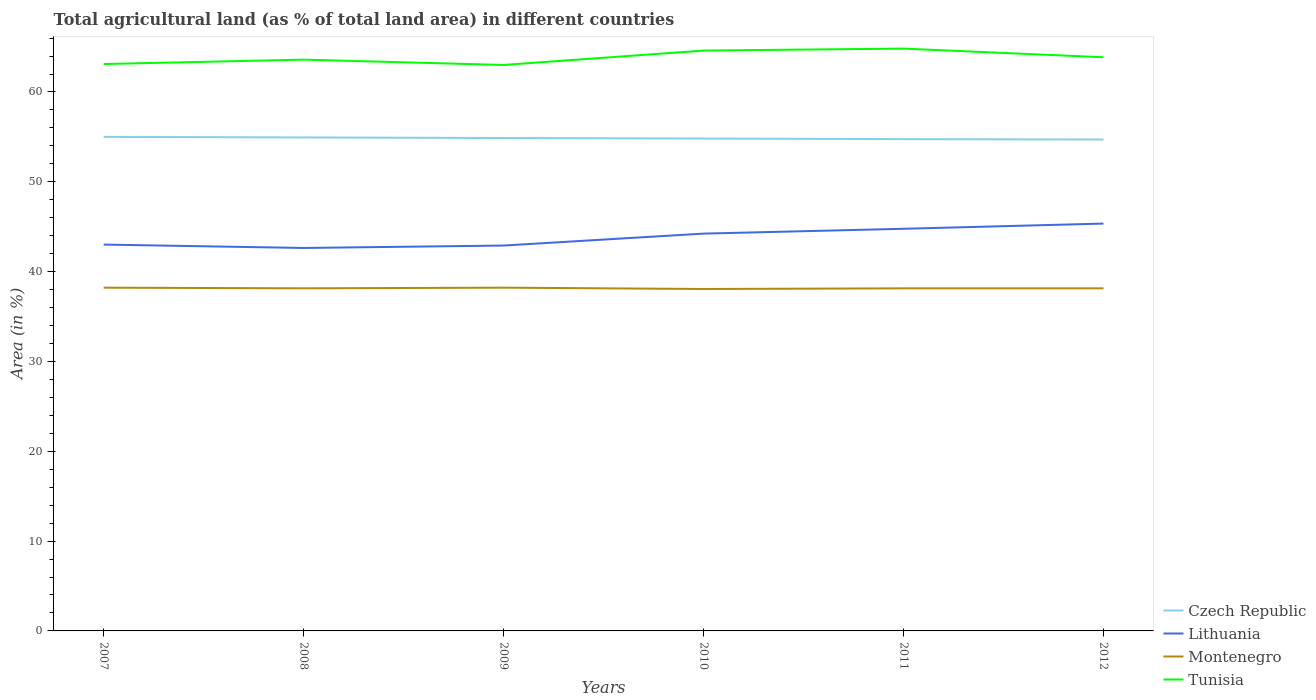Across all years, what is the maximum percentage of agricultural land in Czech Republic?
Provide a short and direct response. 54.71. In which year was the percentage of agricultural land in Czech Republic maximum?
Provide a short and direct response. 2012. What is the total percentage of agricultural land in Tunisia in the graph?
Provide a succinct answer. 0.75. What is the difference between the highest and the second highest percentage of agricultural land in Montenegro?
Offer a terse response. 0.15. What is the difference between the highest and the lowest percentage of agricultural land in Tunisia?
Make the answer very short. 3. Is the percentage of agricultural land in Czech Republic strictly greater than the percentage of agricultural land in Montenegro over the years?
Give a very brief answer. No. How many lines are there?
Your answer should be very brief. 4. How many years are there in the graph?
Keep it short and to the point. 6. Does the graph contain grids?
Offer a very short reply. No. How many legend labels are there?
Keep it short and to the point. 4. What is the title of the graph?
Offer a terse response. Total agricultural land (as % of total land area) in different countries. Does "American Samoa" appear as one of the legend labels in the graph?
Your answer should be compact. No. What is the label or title of the X-axis?
Provide a succinct answer. Years. What is the label or title of the Y-axis?
Offer a very short reply. Area (in %). What is the Area (in %) in Czech Republic in 2007?
Offer a very short reply. 55. What is the Area (in %) in Lithuania in 2007?
Provide a short and direct response. 43.01. What is the Area (in %) of Montenegro in 2007?
Provide a short and direct response. 38.22. What is the Area (in %) in Tunisia in 2007?
Offer a terse response. 63.11. What is the Area (in %) of Czech Republic in 2008?
Your answer should be very brief. 54.94. What is the Area (in %) in Lithuania in 2008?
Offer a terse response. 42.63. What is the Area (in %) of Montenegro in 2008?
Your answer should be compact. 38.14. What is the Area (in %) of Tunisia in 2008?
Provide a succinct answer. 63.6. What is the Area (in %) in Czech Republic in 2009?
Your answer should be very brief. 54.87. What is the Area (in %) of Lithuania in 2009?
Your answer should be compact. 42.9. What is the Area (in %) of Montenegro in 2009?
Your response must be concise. 38.22. What is the Area (in %) of Tunisia in 2009?
Ensure brevity in your answer.  63.01. What is the Area (in %) in Czech Republic in 2010?
Offer a very short reply. 54.82. What is the Area (in %) of Lithuania in 2010?
Offer a terse response. 44.23. What is the Area (in %) of Montenegro in 2010?
Keep it short and to the point. 38.07. What is the Area (in %) of Tunisia in 2010?
Your answer should be compact. 64.61. What is the Area (in %) of Czech Republic in 2011?
Ensure brevity in your answer.  54.75. What is the Area (in %) of Lithuania in 2011?
Ensure brevity in your answer.  44.77. What is the Area (in %) of Montenegro in 2011?
Make the answer very short. 38.14. What is the Area (in %) in Tunisia in 2011?
Give a very brief answer. 64.83. What is the Area (in %) in Czech Republic in 2012?
Your answer should be very brief. 54.71. What is the Area (in %) of Lithuania in 2012?
Keep it short and to the point. 45.35. What is the Area (in %) in Montenegro in 2012?
Your answer should be very brief. 38.14. What is the Area (in %) in Tunisia in 2012?
Ensure brevity in your answer.  63.86. Across all years, what is the maximum Area (in %) in Czech Republic?
Ensure brevity in your answer.  55. Across all years, what is the maximum Area (in %) in Lithuania?
Provide a short and direct response. 45.35. Across all years, what is the maximum Area (in %) of Montenegro?
Provide a succinct answer. 38.22. Across all years, what is the maximum Area (in %) of Tunisia?
Your response must be concise. 64.83. Across all years, what is the minimum Area (in %) of Czech Republic?
Offer a terse response. 54.71. Across all years, what is the minimum Area (in %) of Lithuania?
Give a very brief answer. 42.63. Across all years, what is the minimum Area (in %) in Montenegro?
Offer a terse response. 38.07. Across all years, what is the minimum Area (in %) of Tunisia?
Offer a terse response. 63.01. What is the total Area (in %) in Czech Republic in the graph?
Offer a terse response. 329.09. What is the total Area (in %) of Lithuania in the graph?
Give a very brief answer. 262.9. What is the total Area (in %) of Montenegro in the graph?
Provide a short and direct response. 228.92. What is the total Area (in %) in Tunisia in the graph?
Offer a terse response. 383.03. What is the difference between the Area (in %) in Czech Republic in 2007 and that in 2008?
Ensure brevity in your answer.  0.06. What is the difference between the Area (in %) in Lithuania in 2007 and that in 2008?
Provide a succinct answer. 0.38. What is the difference between the Area (in %) of Montenegro in 2007 and that in 2008?
Offer a very short reply. 0.07. What is the difference between the Area (in %) of Tunisia in 2007 and that in 2008?
Keep it short and to the point. -0.49. What is the difference between the Area (in %) in Czech Republic in 2007 and that in 2009?
Offer a terse response. 0.13. What is the difference between the Area (in %) of Lithuania in 2007 and that in 2009?
Your answer should be very brief. 0.11. What is the difference between the Area (in %) of Montenegro in 2007 and that in 2009?
Ensure brevity in your answer.  0. What is the difference between the Area (in %) of Tunisia in 2007 and that in 2009?
Provide a succinct answer. 0.1. What is the difference between the Area (in %) in Czech Republic in 2007 and that in 2010?
Keep it short and to the point. 0.19. What is the difference between the Area (in %) of Lithuania in 2007 and that in 2010?
Ensure brevity in your answer.  -1.22. What is the difference between the Area (in %) in Montenegro in 2007 and that in 2010?
Keep it short and to the point. 0.15. What is the difference between the Area (in %) of Tunisia in 2007 and that in 2010?
Provide a short and direct response. -1.5. What is the difference between the Area (in %) of Czech Republic in 2007 and that in 2011?
Make the answer very short. 0.25. What is the difference between the Area (in %) of Lithuania in 2007 and that in 2011?
Give a very brief answer. -1.76. What is the difference between the Area (in %) of Montenegro in 2007 and that in 2011?
Provide a short and direct response. 0.07. What is the difference between the Area (in %) in Tunisia in 2007 and that in 2011?
Keep it short and to the point. -1.72. What is the difference between the Area (in %) of Czech Republic in 2007 and that in 2012?
Keep it short and to the point. 0.3. What is the difference between the Area (in %) in Lithuania in 2007 and that in 2012?
Give a very brief answer. -2.34. What is the difference between the Area (in %) of Montenegro in 2007 and that in 2012?
Your response must be concise. 0.07. What is the difference between the Area (in %) in Tunisia in 2007 and that in 2012?
Provide a short and direct response. -0.75. What is the difference between the Area (in %) in Czech Republic in 2008 and that in 2009?
Your answer should be compact. 0.06. What is the difference between the Area (in %) in Lithuania in 2008 and that in 2009?
Your answer should be compact. -0.27. What is the difference between the Area (in %) in Montenegro in 2008 and that in 2009?
Your answer should be compact. -0.07. What is the difference between the Area (in %) in Tunisia in 2008 and that in 2009?
Your answer should be compact. 0.59. What is the difference between the Area (in %) in Czech Republic in 2008 and that in 2010?
Offer a very short reply. 0.12. What is the difference between the Area (in %) of Lithuania in 2008 and that in 2010?
Give a very brief answer. -1.6. What is the difference between the Area (in %) in Montenegro in 2008 and that in 2010?
Ensure brevity in your answer.  0.07. What is the difference between the Area (in %) of Tunisia in 2008 and that in 2010?
Make the answer very short. -1.01. What is the difference between the Area (in %) in Czech Republic in 2008 and that in 2011?
Offer a very short reply. 0.19. What is the difference between the Area (in %) of Lithuania in 2008 and that in 2011?
Ensure brevity in your answer.  -2.14. What is the difference between the Area (in %) of Montenegro in 2008 and that in 2011?
Provide a short and direct response. 0. What is the difference between the Area (in %) in Tunisia in 2008 and that in 2011?
Offer a very short reply. -1.23. What is the difference between the Area (in %) of Czech Republic in 2008 and that in 2012?
Make the answer very short. 0.23. What is the difference between the Area (in %) in Lithuania in 2008 and that in 2012?
Offer a terse response. -2.71. What is the difference between the Area (in %) in Tunisia in 2008 and that in 2012?
Offer a very short reply. -0.26. What is the difference between the Area (in %) in Czech Republic in 2009 and that in 2010?
Your answer should be very brief. 0.06. What is the difference between the Area (in %) of Lithuania in 2009 and that in 2010?
Your answer should be compact. -1.33. What is the difference between the Area (in %) in Montenegro in 2009 and that in 2010?
Ensure brevity in your answer.  0.15. What is the difference between the Area (in %) in Tunisia in 2009 and that in 2010?
Your answer should be very brief. -1.6. What is the difference between the Area (in %) in Czech Republic in 2009 and that in 2011?
Make the answer very short. 0.12. What is the difference between the Area (in %) of Lithuania in 2009 and that in 2011?
Provide a succinct answer. -1.87. What is the difference between the Area (in %) of Montenegro in 2009 and that in 2011?
Provide a short and direct response. 0.07. What is the difference between the Area (in %) of Tunisia in 2009 and that in 2011?
Your response must be concise. -1.82. What is the difference between the Area (in %) of Czech Republic in 2009 and that in 2012?
Provide a succinct answer. 0.17. What is the difference between the Area (in %) in Lithuania in 2009 and that in 2012?
Keep it short and to the point. -2.45. What is the difference between the Area (in %) in Montenegro in 2009 and that in 2012?
Provide a succinct answer. 0.07. What is the difference between the Area (in %) in Tunisia in 2009 and that in 2012?
Keep it short and to the point. -0.86. What is the difference between the Area (in %) of Czech Republic in 2010 and that in 2011?
Make the answer very short. 0.06. What is the difference between the Area (in %) of Lithuania in 2010 and that in 2011?
Offer a terse response. -0.54. What is the difference between the Area (in %) in Montenegro in 2010 and that in 2011?
Your answer should be very brief. -0.07. What is the difference between the Area (in %) of Tunisia in 2010 and that in 2011?
Offer a terse response. -0.22. What is the difference between the Area (in %) in Czech Republic in 2010 and that in 2012?
Keep it short and to the point. 0.11. What is the difference between the Area (in %) of Lithuania in 2010 and that in 2012?
Offer a very short reply. -1.12. What is the difference between the Area (in %) of Montenegro in 2010 and that in 2012?
Offer a very short reply. -0.07. What is the difference between the Area (in %) of Tunisia in 2010 and that in 2012?
Provide a short and direct response. 0.75. What is the difference between the Area (in %) in Czech Republic in 2011 and that in 2012?
Ensure brevity in your answer.  0.04. What is the difference between the Area (in %) of Lithuania in 2011 and that in 2012?
Your response must be concise. -0.58. What is the difference between the Area (in %) in Montenegro in 2011 and that in 2012?
Your response must be concise. 0. What is the difference between the Area (in %) in Tunisia in 2011 and that in 2012?
Give a very brief answer. 0.97. What is the difference between the Area (in %) in Czech Republic in 2007 and the Area (in %) in Lithuania in 2008?
Keep it short and to the point. 12.37. What is the difference between the Area (in %) of Czech Republic in 2007 and the Area (in %) of Montenegro in 2008?
Provide a short and direct response. 16.86. What is the difference between the Area (in %) of Czech Republic in 2007 and the Area (in %) of Tunisia in 2008?
Your answer should be very brief. -8.6. What is the difference between the Area (in %) in Lithuania in 2007 and the Area (in %) in Montenegro in 2008?
Offer a very short reply. 4.87. What is the difference between the Area (in %) of Lithuania in 2007 and the Area (in %) of Tunisia in 2008?
Your response must be concise. -20.59. What is the difference between the Area (in %) in Montenegro in 2007 and the Area (in %) in Tunisia in 2008?
Make the answer very short. -25.39. What is the difference between the Area (in %) of Czech Republic in 2007 and the Area (in %) of Lithuania in 2009?
Your response must be concise. 12.1. What is the difference between the Area (in %) of Czech Republic in 2007 and the Area (in %) of Montenegro in 2009?
Keep it short and to the point. 16.79. What is the difference between the Area (in %) of Czech Republic in 2007 and the Area (in %) of Tunisia in 2009?
Provide a succinct answer. -8.01. What is the difference between the Area (in %) in Lithuania in 2007 and the Area (in %) in Montenegro in 2009?
Provide a short and direct response. 4.79. What is the difference between the Area (in %) in Lithuania in 2007 and the Area (in %) in Tunisia in 2009?
Your answer should be compact. -20. What is the difference between the Area (in %) of Montenegro in 2007 and the Area (in %) of Tunisia in 2009?
Provide a succinct answer. -24.79. What is the difference between the Area (in %) in Czech Republic in 2007 and the Area (in %) in Lithuania in 2010?
Keep it short and to the point. 10.77. What is the difference between the Area (in %) of Czech Republic in 2007 and the Area (in %) of Montenegro in 2010?
Your answer should be very brief. 16.94. What is the difference between the Area (in %) of Czech Republic in 2007 and the Area (in %) of Tunisia in 2010?
Offer a terse response. -9.61. What is the difference between the Area (in %) in Lithuania in 2007 and the Area (in %) in Montenegro in 2010?
Offer a very short reply. 4.94. What is the difference between the Area (in %) in Lithuania in 2007 and the Area (in %) in Tunisia in 2010?
Ensure brevity in your answer.  -21.6. What is the difference between the Area (in %) in Montenegro in 2007 and the Area (in %) in Tunisia in 2010?
Keep it short and to the point. -26.4. What is the difference between the Area (in %) of Czech Republic in 2007 and the Area (in %) of Lithuania in 2011?
Your answer should be compact. 10.23. What is the difference between the Area (in %) of Czech Republic in 2007 and the Area (in %) of Montenegro in 2011?
Keep it short and to the point. 16.86. What is the difference between the Area (in %) in Czech Republic in 2007 and the Area (in %) in Tunisia in 2011?
Your answer should be very brief. -9.83. What is the difference between the Area (in %) of Lithuania in 2007 and the Area (in %) of Montenegro in 2011?
Make the answer very short. 4.87. What is the difference between the Area (in %) of Lithuania in 2007 and the Area (in %) of Tunisia in 2011?
Offer a very short reply. -21.82. What is the difference between the Area (in %) of Montenegro in 2007 and the Area (in %) of Tunisia in 2011?
Offer a terse response. -26.61. What is the difference between the Area (in %) in Czech Republic in 2007 and the Area (in %) in Lithuania in 2012?
Offer a very short reply. 9.65. What is the difference between the Area (in %) of Czech Republic in 2007 and the Area (in %) of Montenegro in 2012?
Provide a short and direct response. 16.86. What is the difference between the Area (in %) in Czech Republic in 2007 and the Area (in %) in Tunisia in 2012?
Keep it short and to the point. -8.86. What is the difference between the Area (in %) of Lithuania in 2007 and the Area (in %) of Montenegro in 2012?
Your answer should be compact. 4.87. What is the difference between the Area (in %) of Lithuania in 2007 and the Area (in %) of Tunisia in 2012?
Provide a short and direct response. -20.85. What is the difference between the Area (in %) in Montenegro in 2007 and the Area (in %) in Tunisia in 2012?
Keep it short and to the point. -25.65. What is the difference between the Area (in %) of Czech Republic in 2008 and the Area (in %) of Lithuania in 2009?
Offer a terse response. 12.03. What is the difference between the Area (in %) of Czech Republic in 2008 and the Area (in %) of Montenegro in 2009?
Provide a succinct answer. 16.72. What is the difference between the Area (in %) of Czech Republic in 2008 and the Area (in %) of Tunisia in 2009?
Make the answer very short. -8.07. What is the difference between the Area (in %) of Lithuania in 2008 and the Area (in %) of Montenegro in 2009?
Keep it short and to the point. 4.42. What is the difference between the Area (in %) of Lithuania in 2008 and the Area (in %) of Tunisia in 2009?
Give a very brief answer. -20.37. What is the difference between the Area (in %) in Montenegro in 2008 and the Area (in %) in Tunisia in 2009?
Your answer should be very brief. -24.87. What is the difference between the Area (in %) of Czech Republic in 2008 and the Area (in %) of Lithuania in 2010?
Offer a very short reply. 10.71. What is the difference between the Area (in %) in Czech Republic in 2008 and the Area (in %) in Montenegro in 2010?
Make the answer very short. 16.87. What is the difference between the Area (in %) of Czech Republic in 2008 and the Area (in %) of Tunisia in 2010?
Your answer should be compact. -9.67. What is the difference between the Area (in %) in Lithuania in 2008 and the Area (in %) in Montenegro in 2010?
Offer a terse response. 4.57. What is the difference between the Area (in %) in Lithuania in 2008 and the Area (in %) in Tunisia in 2010?
Your answer should be compact. -21.98. What is the difference between the Area (in %) in Montenegro in 2008 and the Area (in %) in Tunisia in 2010?
Make the answer very short. -26.47. What is the difference between the Area (in %) in Czech Republic in 2008 and the Area (in %) in Lithuania in 2011?
Your response must be concise. 10.17. What is the difference between the Area (in %) of Czech Republic in 2008 and the Area (in %) of Montenegro in 2011?
Make the answer very short. 16.8. What is the difference between the Area (in %) of Czech Republic in 2008 and the Area (in %) of Tunisia in 2011?
Your answer should be compact. -9.89. What is the difference between the Area (in %) in Lithuania in 2008 and the Area (in %) in Montenegro in 2011?
Give a very brief answer. 4.49. What is the difference between the Area (in %) of Lithuania in 2008 and the Area (in %) of Tunisia in 2011?
Give a very brief answer. -22.2. What is the difference between the Area (in %) of Montenegro in 2008 and the Area (in %) of Tunisia in 2011?
Provide a succinct answer. -26.69. What is the difference between the Area (in %) in Czech Republic in 2008 and the Area (in %) in Lithuania in 2012?
Your answer should be compact. 9.59. What is the difference between the Area (in %) in Czech Republic in 2008 and the Area (in %) in Montenegro in 2012?
Provide a short and direct response. 16.8. What is the difference between the Area (in %) in Czech Republic in 2008 and the Area (in %) in Tunisia in 2012?
Your answer should be compact. -8.93. What is the difference between the Area (in %) of Lithuania in 2008 and the Area (in %) of Montenegro in 2012?
Provide a short and direct response. 4.49. What is the difference between the Area (in %) of Lithuania in 2008 and the Area (in %) of Tunisia in 2012?
Make the answer very short. -21.23. What is the difference between the Area (in %) in Montenegro in 2008 and the Area (in %) in Tunisia in 2012?
Offer a very short reply. -25.72. What is the difference between the Area (in %) in Czech Republic in 2009 and the Area (in %) in Lithuania in 2010?
Your answer should be very brief. 10.64. What is the difference between the Area (in %) of Czech Republic in 2009 and the Area (in %) of Montenegro in 2010?
Give a very brief answer. 16.81. What is the difference between the Area (in %) in Czech Republic in 2009 and the Area (in %) in Tunisia in 2010?
Your response must be concise. -9.74. What is the difference between the Area (in %) in Lithuania in 2009 and the Area (in %) in Montenegro in 2010?
Your answer should be compact. 4.84. What is the difference between the Area (in %) in Lithuania in 2009 and the Area (in %) in Tunisia in 2010?
Your response must be concise. -21.71. What is the difference between the Area (in %) of Montenegro in 2009 and the Area (in %) of Tunisia in 2010?
Your response must be concise. -26.4. What is the difference between the Area (in %) of Czech Republic in 2009 and the Area (in %) of Lithuania in 2011?
Make the answer very short. 10.1. What is the difference between the Area (in %) of Czech Republic in 2009 and the Area (in %) of Montenegro in 2011?
Your response must be concise. 16.73. What is the difference between the Area (in %) in Czech Republic in 2009 and the Area (in %) in Tunisia in 2011?
Your response must be concise. -9.96. What is the difference between the Area (in %) in Lithuania in 2009 and the Area (in %) in Montenegro in 2011?
Keep it short and to the point. 4.76. What is the difference between the Area (in %) in Lithuania in 2009 and the Area (in %) in Tunisia in 2011?
Provide a short and direct response. -21.93. What is the difference between the Area (in %) of Montenegro in 2009 and the Area (in %) of Tunisia in 2011?
Provide a succinct answer. -26.61. What is the difference between the Area (in %) in Czech Republic in 2009 and the Area (in %) in Lithuania in 2012?
Keep it short and to the point. 9.52. What is the difference between the Area (in %) of Czech Republic in 2009 and the Area (in %) of Montenegro in 2012?
Make the answer very short. 16.73. What is the difference between the Area (in %) in Czech Republic in 2009 and the Area (in %) in Tunisia in 2012?
Your answer should be very brief. -8.99. What is the difference between the Area (in %) in Lithuania in 2009 and the Area (in %) in Montenegro in 2012?
Offer a very short reply. 4.76. What is the difference between the Area (in %) of Lithuania in 2009 and the Area (in %) of Tunisia in 2012?
Your answer should be very brief. -20.96. What is the difference between the Area (in %) in Montenegro in 2009 and the Area (in %) in Tunisia in 2012?
Provide a succinct answer. -25.65. What is the difference between the Area (in %) of Czech Republic in 2010 and the Area (in %) of Lithuania in 2011?
Offer a very short reply. 10.05. What is the difference between the Area (in %) of Czech Republic in 2010 and the Area (in %) of Montenegro in 2011?
Provide a succinct answer. 16.67. What is the difference between the Area (in %) of Czech Republic in 2010 and the Area (in %) of Tunisia in 2011?
Your response must be concise. -10.01. What is the difference between the Area (in %) in Lithuania in 2010 and the Area (in %) in Montenegro in 2011?
Offer a terse response. 6.09. What is the difference between the Area (in %) of Lithuania in 2010 and the Area (in %) of Tunisia in 2011?
Your answer should be compact. -20.6. What is the difference between the Area (in %) of Montenegro in 2010 and the Area (in %) of Tunisia in 2011?
Give a very brief answer. -26.76. What is the difference between the Area (in %) of Czech Republic in 2010 and the Area (in %) of Lithuania in 2012?
Give a very brief answer. 9.47. What is the difference between the Area (in %) in Czech Republic in 2010 and the Area (in %) in Montenegro in 2012?
Offer a terse response. 16.67. What is the difference between the Area (in %) in Czech Republic in 2010 and the Area (in %) in Tunisia in 2012?
Keep it short and to the point. -9.05. What is the difference between the Area (in %) in Lithuania in 2010 and the Area (in %) in Montenegro in 2012?
Your response must be concise. 6.09. What is the difference between the Area (in %) of Lithuania in 2010 and the Area (in %) of Tunisia in 2012?
Your response must be concise. -19.63. What is the difference between the Area (in %) in Montenegro in 2010 and the Area (in %) in Tunisia in 2012?
Keep it short and to the point. -25.8. What is the difference between the Area (in %) of Czech Republic in 2011 and the Area (in %) of Lithuania in 2012?
Give a very brief answer. 9.4. What is the difference between the Area (in %) of Czech Republic in 2011 and the Area (in %) of Montenegro in 2012?
Your answer should be very brief. 16.61. What is the difference between the Area (in %) in Czech Republic in 2011 and the Area (in %) in Tunisia in 2012?
Offer a very short reply. -9.11. What is the difference between the Area (in %) of Lithuania in 2011 and the Area (in %) of Montenegro in 2012?
Your answer should be very brief. 6.63. What is the difference between the Area (in %) of Lithuania in 2011 and the Area (in %) of Tunisia in 2012?
Provide a succinct answer. -19.09. What is the difference between the Area (in %) of Montenegro in 2011 and the Area (in %) of Tunisia in 2012?
Ensure brevity in your answer.  -25.72. What is the average Area (in %) in Czech Republic per year?
Make the answer very short. 54.85. What is the average Area (in %) of Lithuania per year?
Make the answer very short. 43.82. What is the average Area (in %) in Montenegro per year?
Offer a terse response. 38.15. What is the average Area (in %) in Tunisia per year?
Ensure brevity in your answer.  63.84. In the year 2007, what is the difference between the Area (in %) in Czech Republic and Area (in %) in Lithuania?
Your response must be concise. 11.99. In the year 2007, what is the difference between the Area (in %) of Czech Republic and Area (in %) of Montenegro?
Ensure brevity in your answer.  16.79. In the year 2007, what is the difference between the Area (in %) of Czech Republic and Area (in %) of Tunisia?
Provide a short and direct response. -8.11. In the year 2007, what is the difference between the Area (in %) of Lithuania and Area (in %) of Montenegro?
Provide a succinct answer. 4.79. In the year 2007, what is the difference between the Area (in %) in Lithuania and Area (in %) in Tunisia?
Offer a very short reply. -20.1. In the year 2007, what is the difference between the Area (in %) of Montenegro and Area (in %) of Tunisia?
Your answer should be compact. -24.9. In the year 2008, what is the difference between the Area (in %) of Czech Republic and Area (in %) of Lithuania?
Ensure brevity in your answer.  12.3. In the year 2008, what is the difference between the Area (in %) in Czech Republic and Area (in %) in Montenegro?
Provide a succinct answer. 16.8. In the year 2008, what is the difference between the Area (in %) of Czech Republic and Area (in %) of Tunisia?
Your answer should be compact. -8.66. In the year 2008, what is the difference between the Area (in %) in Lithuania and Area (in %) in Montenegro?
Provide a succinct answer. 4.49. In the year 2008, what is the difference between the Area (in %) in Lithuania and Area (in %) in Tunisia?
Ensure brevity in your answer.  -20.97. In the year 2008, what is the difference between the Area (in %) in Montenegro and Area (in %) in Tunisia?
Your answer should be very brief. -25.46. In the year 2009, what is the difference between the Area (in %) in Czech Republic and Area (in %) in Lithuania?
Your response must be concise. 11.97. In the year 2009, what is the difference between the Area (in %) of Czech Republic and Area (in %) of Montenegro?
Make the answer very short. 16.66. In the year 2009, what is the difference between the Area (in %) in Czech Republic and Area (in %) in Tunisia?
Your answer should be compact. -8.13. In the year 2009, what is the difference between the Area (in %) in Lithuania and Area (in %) in Montenegro?
Offer a very short reply. 4.69. In the year 2009, what is the difference between the Area (in %) of Lithuania and Area (in %) of Tunisia?
Provide a succinct answer. -20.1. In the year 2009, what is the difference between the Area (in %) in Montenegro and Area (in %) in Tunisia?
Provide a succinct answer. -24.79. In the year 2010, what is the difference between the Area (in %) of Czech Republic and Area (in %) of Lithuania?
Provide a succinct answer. 10.58. In the year 2010, what is the difference between the Area (in %) in Czech Republic and Area (in %) in Montenegro?
Offer a terse response. 16.75. In the year 2010, what is the difference between the Area (in %) of Czech Republic and Area (in %) of Tunisia?
Offer a terse response. -9.8. In the year 2010, what is the difference between the Area (in %) in Lithuania and Area (in %) in Montenegro?
Offer a terse response. 6.17. In the year 2010, what is the difference between the Area (in %) in Lithuania and Area (in %) in Tunisia?
Ensure brevity in your answer.  -20.38. In the year 2010, what is the difference between the Area (in %) in Montenegro and Area (in %) in Tunisia?
Your response must be concise. -26.54. In the year 2011, what is the difference between the Area (in %) of Czech Republic and Area (in %) of Lithuania?
Keep it short and to the point. 9.98. In the year 2011, what is the difference between the Area (in %) of Czech Republic and Area (in %) of Montenegro?
Ensure brevity in your answer.  16.61. In the year 2011, what is the difference between the Area (in %) in Czech Republic and Area (in %) in Tunisia?
Ensure brevity in your answer.  -10.08. In the year 2011, what is the difference between the Area (in %) in Lithuania and Area (in %) in Montenegro?
Provide a succinct answer. 6.63. In the year 2011, what is the difference between the Area (in %) of Lithuania and Area (in %) of Tunisia?
Make the answer very short. -20.06. In the year 2011, what is the difference between the Area (in %) in Montenegro and Area (in %) in Tunisia?
Offer a terse response. -26.69. In the year 2012, what is the difference between the Area (in %) in Czech Republic and Area (in %) in Lithuania?
Keep it short and to the point. 9.36. In the year 2012, what is the difference between the Area (in %) in Czech Republic and Area (in %) in Montenegro?
Provide a short and direct response. 16.57. In the year 2012, what is the difference between the Area (in %) in Czech Republic and Area (in %) in Tunisia?
Offer a very short reply. -9.16. In the year 2012, what is the difference between the Area (in %) in Lithuania and Area (in %) in Montenegro?
Make the answer very short. 7.21. In the year 2012, what is the difference between the Area (in %) of Lithuania and Area (in %) of Tunisia?
Your answer should be compact. -18.52. In the year 2012, what is the difference between the Area (in %) in Montenegro and Area (in %) in Tunisia?
Your answer should be very brief. -25.72. What is the ratio of the Area (in %) in Lithuania in 2007 to that in 2008?
Your response must be concise. 1.01. What is the ratio of the Area (in %) in Tunisia in 2007 to that in 2008?
Offer a terse response. 0.99. What is the ratio of the Area (in %) in Czech Republic in 2007 to that in 2009?
Offer a very short reply. 1. What is the ratio of the Area (in %) in Lithuania in 2007 to that in 2009?
Your response must be concise. 1. What is the ratio of the Area (in %) in Montenegro in 2007 to that in 2009?
Keep it short and to the point. 1. What is the ratio of the Area (in %) in Czech Republic in 2007 to that in 2010?
Provide a short and direct response. 1. What is the ratio of the Area (in %) of Lithuania in 2007 to that in 2010?
Offer a terse response. 0.97. What is the ratio of the Area (in %) of Montenegro in 2007 to that in 2010?
Provide a succinct answer. 1. What is the ratio of the Area (in %) in Tunisia in 2007 to that in 2010?
Your answer should be compact. 0.98. What is the ratio of the Area (in %) in Lithuania in 2007 to that in 2011?
Make the answer very short. 0.96. What is the ratio of the Area (in %) of Tunisia in 2007 to that in 2011?
Make the answer very short. 0.97. What is the ratio of the Area (in %) in Czech Republic in 2007 to that in 2012?
Your answer should be compact. 1.01. What is the ratio of the Area (in %) in Lithuania in 2007 to that in 2012?
Offer a terse response. 0.95. What is the ratio of the Area (in %) of Czech Republic in 2008 to that in 2009?
Ensure brevity in your answer.  1. What is the ratio of the Area (in %) in Lithuania in 2008 to that in 2009?
Your answer should be very brief. 0.99. What is the ratio of the Area (in %) in Tunisia in 2008 to that in 2009?
Keep it short and to the point. 1.01. What is the ratio of the Area (in %) in Lithuania in 2008 to that in 2010?
Offer a terse response. 0.96. What is the ratio of the Area (in %) of Montenegro in 2008 to that in 2010?
Keep it short and to the point. 1. What is the ratio of the Area (in %) of Tunisia in 2008 to that in 2010?
Give a very brief answer. 0.98. What is the ratio of the Area (in %) in Lithuania in 2008 to that in 2011?
Provide a succinct answer. 0.95. What is the ratio of the Area (in %) of Montenegro in 2008 to that in 2011?
Offer a terse response. 1. What is the ratio of the Area (in %) of Tunisia in 2008 to that in 2011?
Your response must be concise. 0.98. What is the ratio of the Area (in %) of Lithuania in 2008 to that in 2012?
Your answer should be very brief. 0.94. What is the ratio of the Area (in %) in Lithuania in 2009 to that in 2010?
Offer a very short reply. 0.97. What is the ratio of the Area (in %) in Tunisia in 2009 to that in 2010?
Offer a terse response. 0.98. What is the ratio of the Area (in %) of Czech Republic in 2009 to that in 2011?
Offer a terse response. 1. What is the ratio of the Area (in %) of Lithuania in 2009 to that in 2011?
Provide a short and direct response. 0.96. What is the ratio of the Area (in %) in Montenegro in 2009 to that in 2011?
Give a very brief answer. 1. What is the ratio of the Area (in %) in Tunisia in 2009 to that in 2011?
Your response must be concise. 0.97. What is the ratio of the Area (in %) of Lithuania in 2009 to that in 2012?
Your response must be concise. 0.95. What is the ratio of the Area (in %) of Montenegro in 2009 to that in 2012?
Provide a short and direct response. 1. What is the ratio of the Area (in %) of Tunisia in 2009 to that in 2012?
Your answer should be compact. 0.99. What is the ratio of the Area (in %) of Lithuania in 2010 to that in 2011?
Your response must be concise. 0.99. What is the ratio of the Area (in %) in Tunisia in 2010 to that in 2011?
Offer a very short reply. 1. What is the ratio of the Area (in %) in Lithuania in 2010 to that in 2012?
Ensure brevity in your answer.  0.98. What is the ratio of the Area (in %) of Montenegro in 2010 to that in 2012?
Offer a terse response. 1. What is the ratio of the Area (in %) in Tunisia in 2010 to that in 2012?
Your response must be concise. 1.01. What is the ratio of the Area (in %) of Lithuania in 2011 to that in 2012?
Ensure brevity in your answer.  0.99. What is the ratio of the Area (in %) in Montenegro in 2011 to that in 2012?
Keep it short and to the point. 1. What is the ratio of the Area (in %) in Tunisia in 2011 to that in 2012?
Make the answer very short. 1.02. What is the difference between the highest and the second highest Area (in %) in Czech Republic?
Give a very brief answer. 0.06. What is the difference between the highest and the second highest Area (in %) in Lithuania?
Offer a terse response. 0.58. What is the difference between the highest and the second highest Area (in %) of Tunisia?
Keep it short and to the point. 0.22. What is the difference between the highest and the lowest Area (in %) in Czech Republic?
Your answer should be compact. 0.3. What is the difference between the highest and the lowest Area (in %) in Lithuania?
Offer a terse response. 2.71. What is the difference between the highest and the lowest Area (in %) of Montenegro?
Provide a succinct answer. 0.15. What is the difference between the highest and the lowest Area (in %) in Tunisia?
Offer a very short reply. 1.82. 